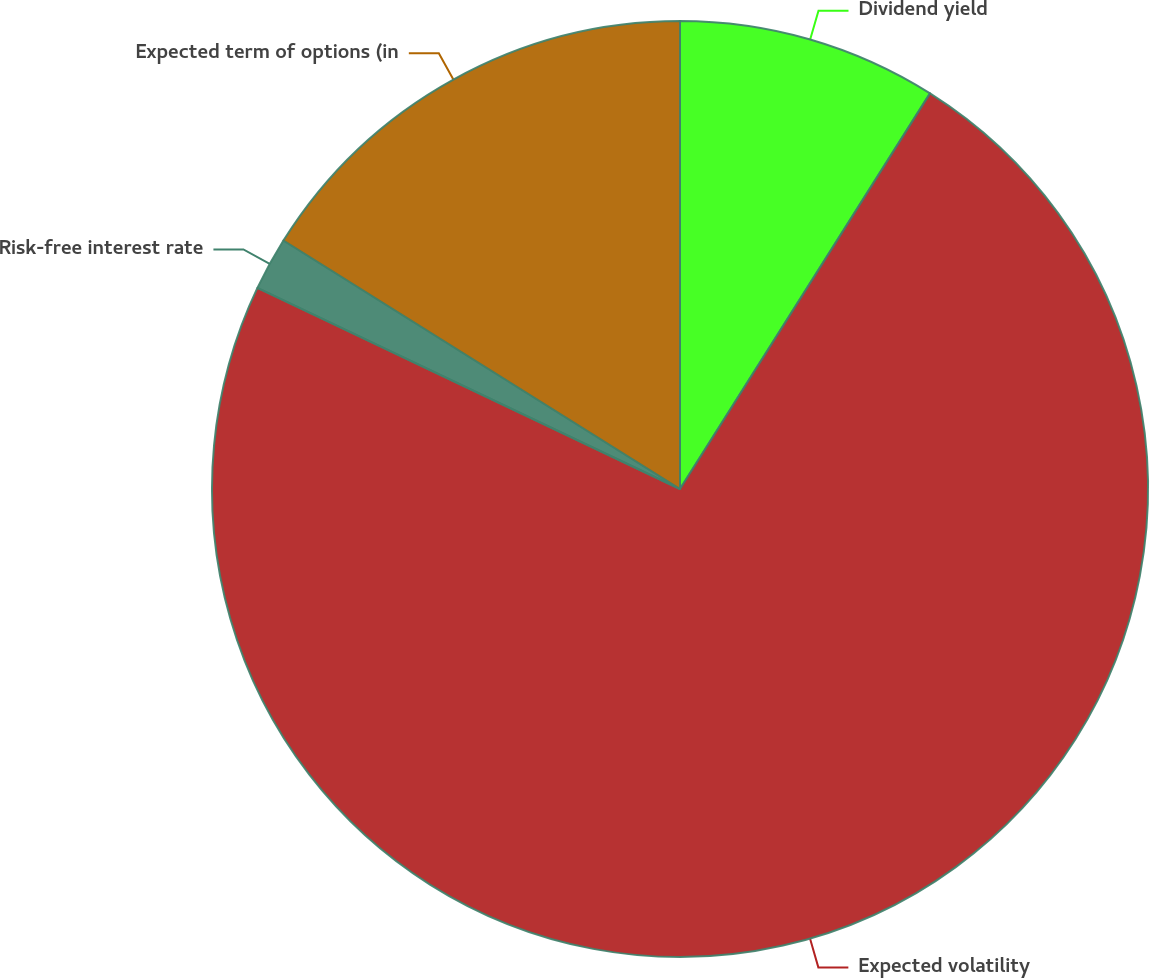Convert chart to OTSL. <chart><loc_0><loc_0><loc_500><loc_500><pie_chart><fcel>Dividend yield<fcel>Expected volatility<fcel>Risk-free interest rate<fcel>Expected term of options (in<nl><fcel>8.97%<fcel>73.09%<fcel>1.84%<fcel>16.09%<nl></chart> 